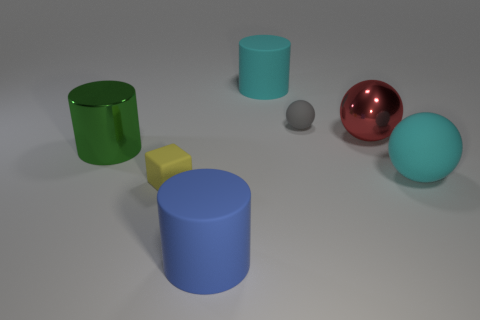Add 1 big blue matte cylinders. How many objects exist? 8 Subtract all blocks. How many objects are left? 6 Subtract all large red balls. Subtract all big red things. How many objects are left? 5 Add 2 small rubber cubes. How many small rubber cubes are left? 3 Add 1 green metallic cylinders. How many green metallic cylinders exist? 2 Subtract 1 red spheres. How many objects are left? 6 